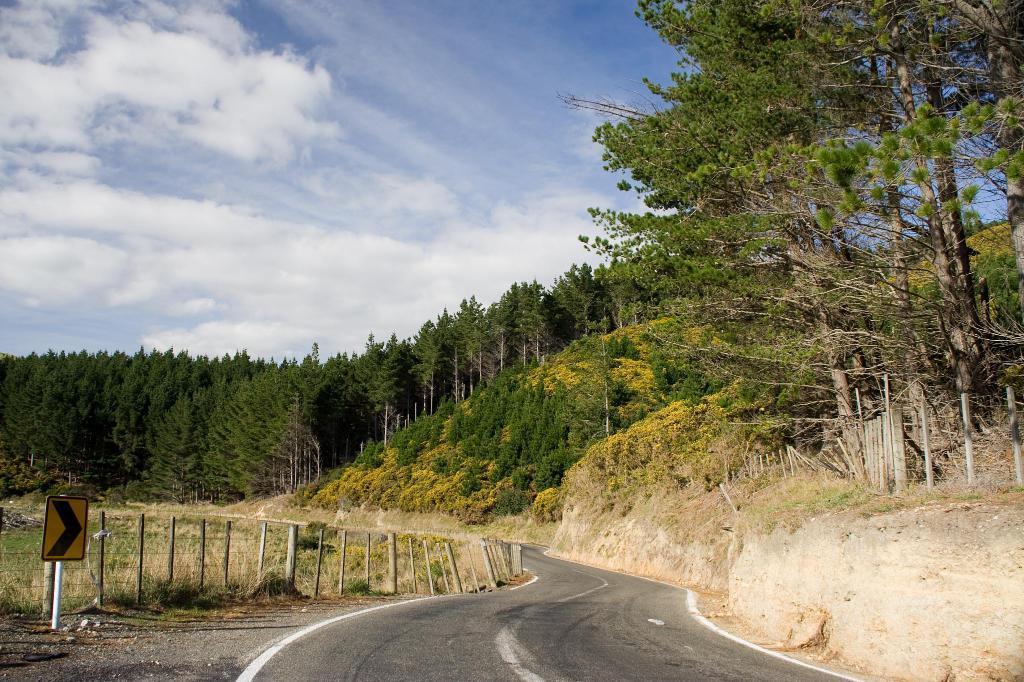How would you summarize this image in a sentence or two? In this image I can see the road, few poles, the railing , a pole with a board to it and few trees which are green and yellow in color. In the background I can see the sky. 